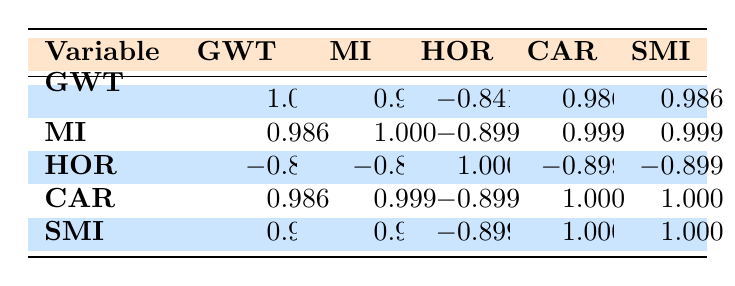What is the Generational Wealth Transfer for the Urban location with the highest value? In the table, we can examine the "Generational Wealth Transfer" values specifically for the Urban location. The highest value listed is 200000.
Answer: 200000 What is the median income for the Rural location with the lowest home ownership rate? From the table, the Rural data points show home ownership rates of 75, 80, and 70. The lowest rate among these is 70, which corresponds to a median income of 48000.
Answer: 48000 Is the Social Mobility Index for Urban locations generally higher than that for Rural locations? The Social Mobility Index values for Urban locations are 75, 80, and 70. For Rural locations, the values are 50, 55, and 45. All Urban values are higher than those of Rural locations.
Answer: Yes What is the correlation coefficient between Home Ownership Rate and Median Income? Looking at the correlation table, we focus on the values related to Home Ownership Rate and Median Income, which is -0.899, representing a negative correlation.
Answer: -0.899 What is the average Generational Wealth Transfer for Rural locations? To calculate the average, we sum the Generational Wealth Transfer values for the Rural locations: 80000 + 100000 + 60000 = 240000. There are three data points (locations), so the average is 240000 / 3 = 80000.
Answer: 80000 What is the relationship between College Attendance Rate and Social Mobility Index in Urban locations? For Urban locations, the College Attendance Rates are 65, 70, and 60, while the corresponding Social Mobility Index values are 75, 80, and 70. The correlation is positive, with both values increasing together.
Answer: Positive Does a higher Generational Wealth Transfer correlate with a lower Home Ownership Rate? According to the correlation table, the coefficient between Generational Wealth Transfer and Home Ownership Rate is -0.841, indicating a negative correlation. Thus, as Generational Wealth Transfer increases, Home Ownership Rate tends to decrease.
Answer: Yes What is the difference in the median incomes between Urban and Rural locations? The median incomes for Urban locations are 75000, 85000, and 70000, which average to 76666.67. The Rural median incomes (50000, 55000, 48000) average out to 51000. The difference is 76666.67 - 51000 = 25666.67.
Answer: 25666.67 How many locations have a College Attendance Rate above 60? In the table, we find Urban rates of 65, 70, and 60, along with Rural rates of 40, 45, and 35. The only values above 60 are Urban: 65 and 70. Therefore, there are two locations with a College Attendance Rate above 60.
Answer: 2 